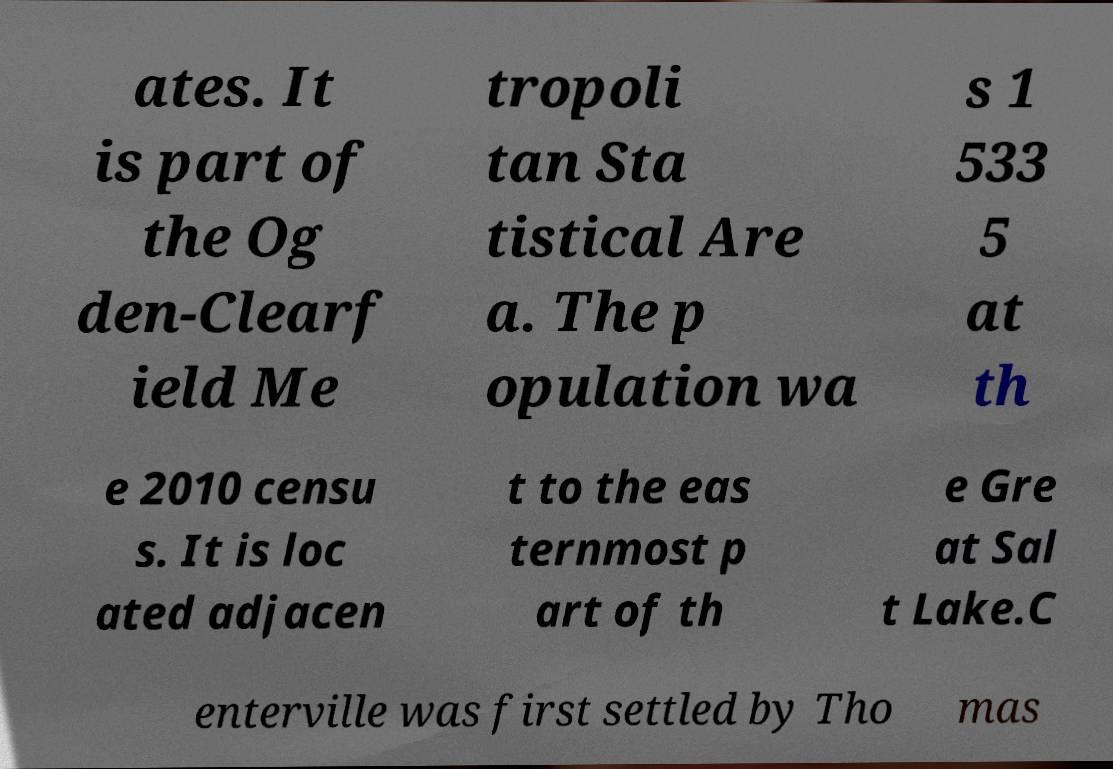Please read and relay the text visible in this image. What does it say? ates. It is part of the Og den-Clearf ield Me tropoli tan Sta tistical Are a. The p opulation wa s 1 533 5 at th e 2010 censu s. It is loc ated adjacen t to the eas ternmost p art of th e Gre at Sal t Lake.C enterville was first settled by Tho mas 